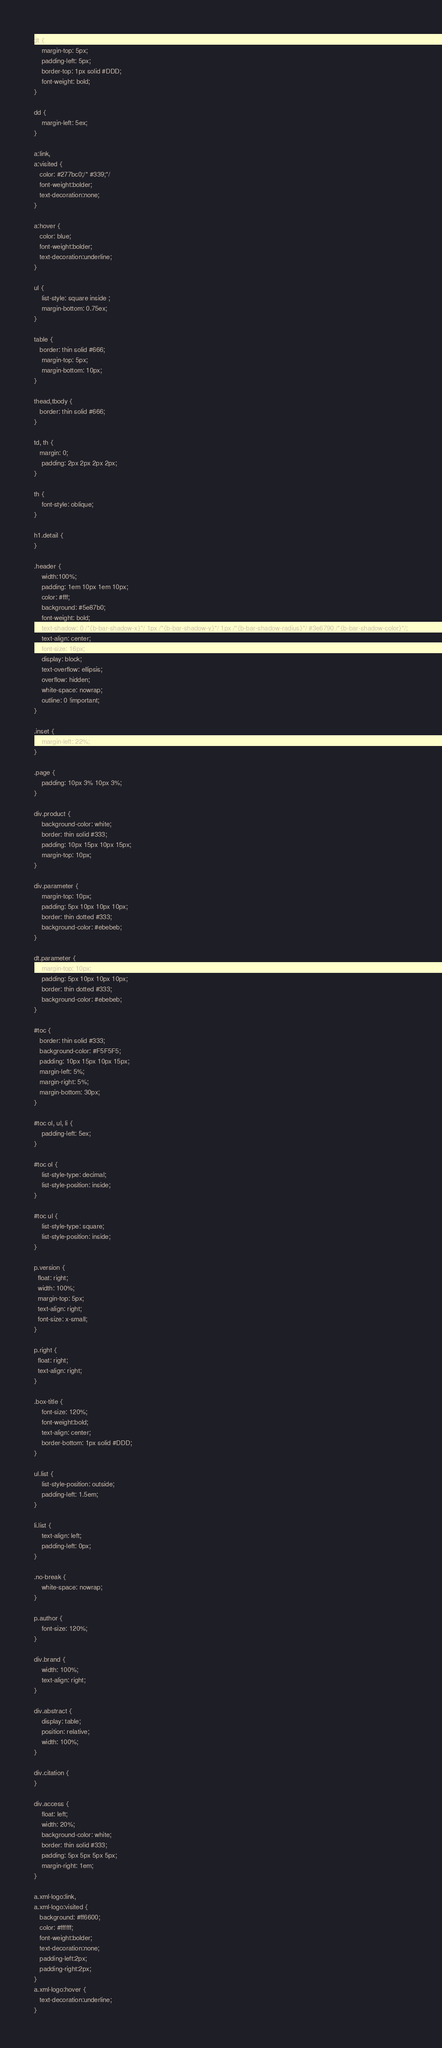<code> <loc_0><loc_0><loc_500><loc_500><_HTML_>dt {
	margin-top: 5px;
	padding-left: 5px;
	border-top: 1px solid #DDD;
	font-weight: bold;
}

dd {
	margin-left: 5ex;
}

a:link,
a:visited {
   color: #277bc0;/* #339;*/
   font-weight:bolder; 
   text-decoration:none; 
}

a:hover {
   color: blue;
   font-weight:bolder; 
   text-decoration:underline; 
}

ul {
	list-style: square inside ;
	margin-bottom: 0.75ex;
}

table {
   border: thin solid #666;
	margin-top: 5px;
	margin-bottom: 10px;
}

thead,tbody {
   border: thin solid #666;
}

td, th {
   margin: 0;
	padding: 2px 2px 2px 2px;
}

th {
	font-style: oblique;
}

h1.detail {
}

.header {
	width:100%;
	padding: 1em 10px 1em 10px;
	color: #fff;
	background: #5e87b0;
	font-weight: bold;
	text-shadow: 0 /*{b-bar-shadow-x}*/ 1px /*{b-bar-shadow-y}*/ 1px /*{b-bar-shadow-radius}*/ #3e6790 /*{b-bar-shadow-color}*/;
	text-align: center;
	font-size: 16px;
	display: block;
	text-overflow: ellipsis;
	overflow: hidden;
	white-space: nowrap;
	outline: 0 !important;
}

.inset {
	margin-left: 22%;
}

.page {
	padding: 10px 3% 10px 3%;
}

div.product {
	background-color: white;
	border: thin solid #333;
	padding: 10px 15px 10px 15px;
	margin-top: 10px;
}

div.parameter {
	margin-top: 10px;
	padding: 5px 10px 10px 10px;
	border: thin dotted #333;
	background-color: #ebebeb;
}

dt.parameter {
	margin-top: 10px;
	padding: 5px 10px 10px 10px;
	border: thin dotted #333;
	background-color: #ebebeb;
}

#toc {
   border: thin solid #333;
   background-color: #F5F5F5; 
   padding: 10px 15px 10px 15px;
   margin-left: 5%;
   margin-right: 5%;
   margin-bottom: 30px;
}

#toc ol, ul, li {
	padding-left: 5ex;
}

#toc ol {
	list-style-type: decimal;
	list-style-position: inside; 
}

#toc ul {
	list-style-type: square;
	list-style-position: inside; 
}

p.version {
  float: right;
  width: 100%;
  margin-top: 5px;
  text-align: right;
  font-size: x-small;
}

p.right {
  float: right;
  text-align: right;
}

.box-title {
	font-size: 120%;
	font-weight:bold;
	text-align: center;
	border-bottom: 1px solid #DDD;
}

ul.list {
	list-style-position: outside;
	padding-left: 1.5em;
}

li.list {
	text-align: left;
	padding-left: 0px;
}

.no-break {
	white-space: nowrap;
}

p.author {
	font-size: 120%;
}

div.brand {
	width: 100%;
	text-align: right;
}

div.abstract {
	display: table;
	position: relative;
	width: 100%;
}

div.citation {
}

div.access {
	float: left;
	width: 20%;
	background-color: white;
	border: thin solid #333;
	padding: 5px 5px 5px 5px;
	margin-right: 1em;
}

a.xml-logo:link,
a.xml-logo:visited {
   background: #ff6600;
   color: #ffffff;
   font-weight:bolder; 
   text-decoration:none; 
   padding-left:2px;
   padding-right:2px;
}
a.xml-logo:hover {
   text-decoration:underline; 
}
</code> 